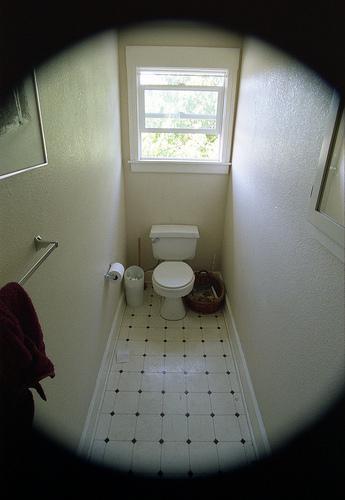How many towel racks are there?
Give a very brief answer. 1. 